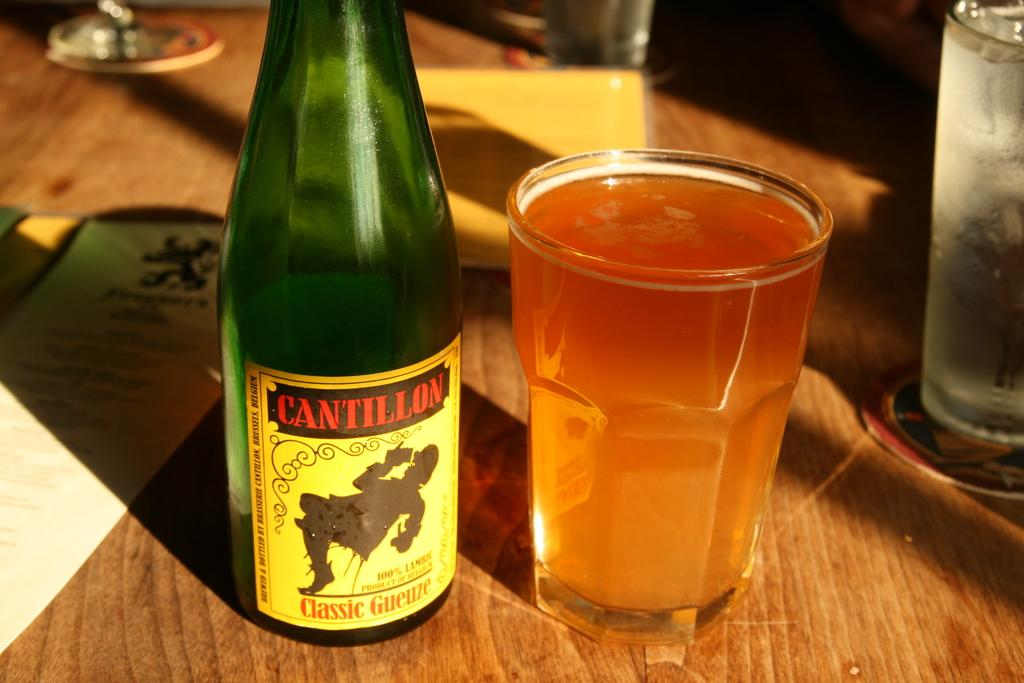<image>
Write a terse but informative summary of the picture. Bottle of Cantillon next to a full cup of beer on a table. 